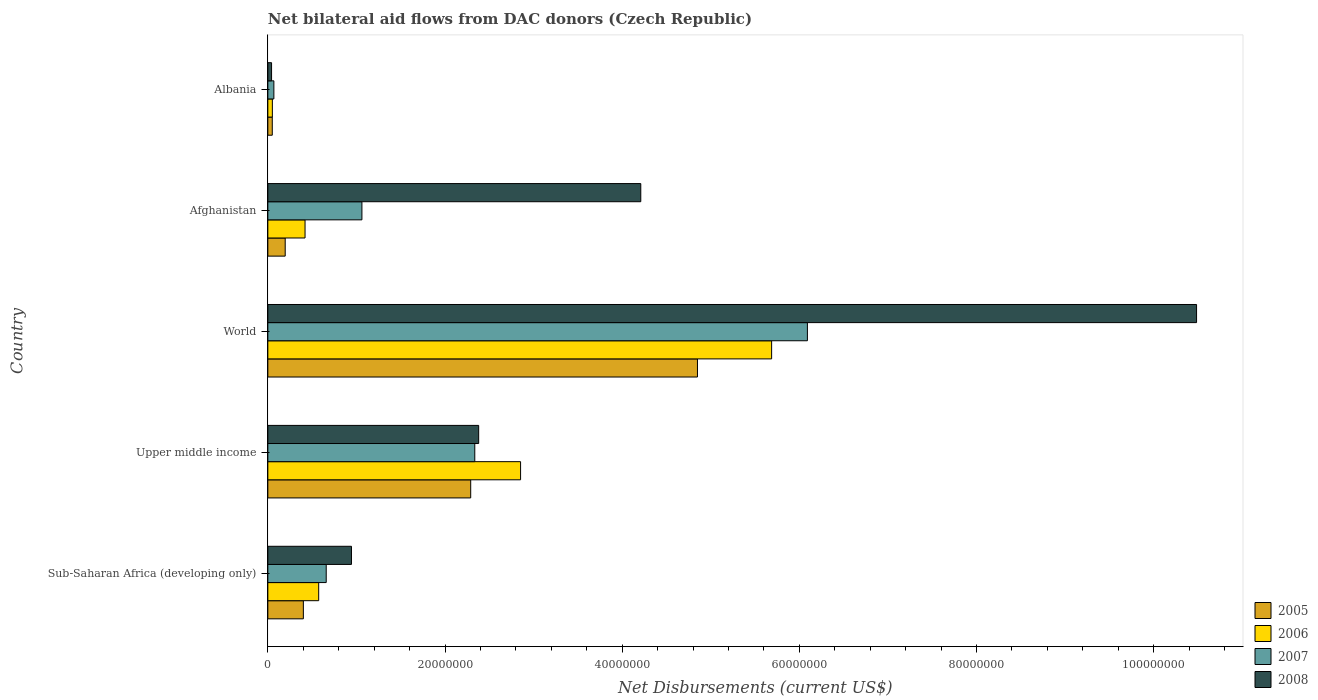How many different coloured bars are there?
Ensure brevity in your answer.  4. Are the number of bars per tick equal to the number of legend labels?
Keep it short and to the point. Yes. Are the number of bars on each tick of the Y-axis equal?
Your answer should be compact. Yes. How many bars are there on the 5th tick from the bottom?
Offer a very short reply. 4. What is the label of the 1st group of bars from the top?
Offer a terse response. Albania. What is the net bilateral aid flows in 2005 in Sub-Saharan Africa (developing only)?
Your answer should be very brief. 4.01e+06. Across all countries, what is the maximum net bilateral aid flows in 2005?
Offer a terse response. 4.85e+07. Across all countries, what is the minimum net bilateral aid flows in 2008?
Keep it short and to the point. 4.20e+05. In which country was the net bilateral aid flows in 2006 maximum?
Your answer should be very brief. World. In which country was the net bilateral aid flows in 2005 minimum?
Provide a short and direct response. Albania. What is the total net bilateral aid flows in 2008 in the graph?
Keep it short and to the point. 1.81e+08. What is the difference between the net bilateral aid flows in 2006 in Afghanistan and that in Upper middle income?
Ensure brevity in your answer.  -2.43e+07. What is the difference between the net bilateral aid flows in 2007 in World and the net bilateral aid flows in 2006 in Upper middle income?
Provide a succinct answer. 3.24e+07. What is the average net bilateral aid flows in 2005 per country?
Offer a very short reply. 1.56e+07. What is the difference between the net bilateral aid flows in 2005 and net bilateral aid flows in 2006 in Upper middle income?
Make the answer very short. -5.63e+06. What is the ratio of the net bilateral aid flows in 2008 in Albania to that in World?
Offer a very short reply. 0. Is the difference between the net bilateral aid flows in 2005 in Upper middle income and World greater than the difference between the net bilateral aid flows in 2006 in Upper middle income and World?
Make the answer very short. Yes. What is the difference between the highest and the second highest net bilateral aid flows in 2008?
Offer a very short reply. 6.27e+07. What is the difference between the highest and the lowest net bilateral aid flows in 2007?
Your answer should be compact. 6.02e+07. Is it the case that in every country, the sum of the net bilateral aid flows in 2007 and net bilateral aid flows in 2008 is greater than the sum of net bilateral aid flows in 2006 and net bilateral aid flows in 2005?
Provide a short and direct response. No. What does the 4th bar from the top in World represents?
Offer a very short reply. 2005. What does the 3rd bar from the bottom in Upper middle income represents?
Offer a very short reply. 2007. How many bars are there?
Offer a terse response. 20. Are all the bars in the graph horizontal?
Provide a short and direct response. Yes. What is the difference between two consecutive major ticks on the X-axis?
Your answer should be very brief. 2.00e+07. Are the values on the major ticks of X-axis written in scientific E-notation?
Make the answer very short. No. Does the graph contain grids?
Provide a short and direct response. No. How many legend labels are there?
Your answer should be very brief. 4. What is the title of the graph?
Give a very brief answer. Net bilateral aid flows from DAC donors (Czech Republic). What is the label or title of the X-axis?
Provide a succinct answer. Net Disbursements (current US$). What is the Net Disbursements (current US$) of 2005 in Sub-Saharan Africa (developing only)?
Your answer should be very brief. 4.01e+06. What is the Net Disbursements (current US$) of 2006 in Sub-Saharan Africa (developing only)?
Make the answer very short. 5.74e+06. What is the Net Disbursements (current US$) of 2007 in Sub-Saharan Africa (developing only)?
Give a very brief answer. 6.59e+06. What is the Net Disbursements (current US$) in 2008 in Sub-Saharan Africa (developing only)?
Your response must be concise. 9.44e+06. What is the Net Disbursements (current US$) of 2005 in Upper middle income?
Provide a succinct answer. 2.29e+07. What is the Net Disbursements (current US$) in 2006 in Upper middle income?
Your answer should be very brief. 2.85e+07. What is the Net Disbursements (current US$) in 2007 in Upper middle income?
Give a very brief answer. 2.34e+07. What is the Net Disbursements (current US$) in 2008 in Upper middle income?
Your response must be concise. 2.38e+07. What is the Net Disbursements (current US$) in 2005 in World?
Your answer should be compact. 4.85e+07. What is the Net Disbursements (current US$) of 2006 in World?
Provide a succinct answer. 5.69e+07. What is the Net Disbursements (current US$) in 2007 in World?
Give a very brief answer. 6.09e+07. What is the Net Disbursements (current US$) of 2008 in World?
Your answer should be compact. 1.05e+08. What is the Net Disbursements (current US$) of 2005 in Afghanistan?
Provide a short and direct response. 1.96e+06. What is the Net Disbursements (current US$) of 2006 in Afghanistan?
Your response must be concise. 4.20e+06. What is the Net Disbursements (current US$) of 2007 in Afghanistan?
Provide a short and direct response. 1.06e+07. What is the Net Disbursements (current US$) in 2008 in Afghanistan?
Offer a very short reply. 4.21e+07. What is the Net Disbursements (current US$) in 2005 in Albania?
Provide a short and direct response. 5.00e+05. What is the Net Disbursements (current US$) of 2006 in Albania?
Your answer should be very brief. 5.10e+05. What is the Net Disbursements (current US$) in 2007 in Albania?
Your answer should be compact. 6.80e+05. Across all countries, what is the maximum Net Disbursements (current US$) of 2005?
Your response must be concise. 4.85e+07. Across all countries, what is the maximum Net Disbursements (current US$) of 2006?
Give a very brief answer. 5.69e+07. Across all countries, what is the maximum Net Disbursements (current US$) of 2007?
Give a very brief answer. 6.09e+07. Across all countries, what is the maximum Net Disbursements (current US$) of 2008?
Make the answer very short. 1.05e+08. Across all countries, what is the minimum Net Disbursements (current US$) in 2005?
Make the answer very short. 5.00e+05. Across all countries, what is the minimum Net Disbursements (current US$) of 2006?
Provide a succinct answer. 5.10e+05. Across all countries, what is the minimum Net Disbursements (current US$) in 2007?
Your answer should be compact. 6.80e+05. Across all countries, what is the minimum Net Disbursements (current US$) of 2008?
Your response must be concise. 4.20e+05. What is the total Net Disbursements (current US$) of 2005 in the graph?
Keep it short and to the point. 7.79e+07. What is the total Net Disbursements (current US$) of 2006 in the graph?
Make the answer very short. 9.58e+07. What is the total Net Disbursements (current US$) of 2007 in the graph?
Provide a short and direct response. 1.02e+08. What is the total Net Disbursements (current US$) in 2008 in the graph?
Give a very brief answer. 1.81e+08. What is the difference between the Net Disbursements (current US$) of 2005 in Sub-Saharan Africa (developing only) and that in Upper middle income?
Provide a short and direct response. -1.89e+07. What is the difference between the Net Disbursements (current US$) of 2006 in Sub-Saharan Africa (developing only) and that in Upper middle income?
Your answer should be compact. -2.28e+07. What is the difference between the Net Disbursements (current US$) in 2007 in Sub-Saharan Africa (developing only) and that in Upper middle income?
Ensure brevity in your answer.  -1.68e+07. What is the difference between the Net Disbursements (current US$) of 2008 in Sub-Saharan Africa (developing only) and that in Upper middle income?
Give a very brief answer. -1.44e+07. What is the difference between the Net Disbursements (current US$) in 2005 in Sub-Saharan Africa (developing only) and that in World?
Keep it short and to the point. -4.45e+07. What is the difference between the Net Disbursements (current US$) of 2006 in Sub-Saharan Africa (developing only) and that in World?
Offer a very short reply. -5.11e+07. What is the difference between the Net Disbursements (current US$) in 2007 in Sub-Saharan Africa (developing only) and that in World?
Your answer should be compact. -5.43e+07. What is the difference between the Net Disbursements (current US$) in 2008 in Sub-Saharan Africa (developing only) and that in World?
Offer a very short reply. -9.54e+07. What is the difference between the Net Disbursements (current US$) in 2005 in Sub-Saharan Africa (developing only) and that in Afghanistan?
Offer a very short reply. 2.05e+06. What is the difference between the Net Disbursements (current US$) of 2006 in Sub-Saharan Africa (developing only) and that in Afghanistan?
Keep it short and to the point. 1.54e+06. What is the difference between the Net Disbursements (current US$) in 2007 in Sub-Saharan Africa (developing only) and that in Afghanistan?
Offer a terse response. -4.03e+06. What is the difference between the Net Disbursements (current US$) of 2008 in Sub-Saharan Africa (developing only) and that in Afghanistan?
Your response must be concise. -3.27e+07. What is the difference between the Net Disbursements (current US$) of 2005 in Sub-Saharan Africa (developing only) and that in Albania?
Offer a terse response. 3.51e+06. What is the difference between the Net Disbursements (current US$) of 2006 in Sub-Saharan Africa (developing only) and that in Albania?
Ensure brevity in your answer.  5.23e+06. What is the difference between the Net Disbursements (current US$) of 2007 in Sub-Saharan Africa (developing only) and that in Albania?
Give a very brief answer. 5.91e+06. What is the difference between the Net Disbursements (current US$) in 2008 in Sub-Saharan Africa (developing only) and that in Albania?
Offer a very short reply. 9.02e+06. What is the difference between the Net Disbursements (current US$) in 2005 in Upper middle income and that in World?
Give a very brief answer. -2.56e+07. What is the difference between the Net Disbursements (current US$) in 2006 in Upper middle income and that in World?
Offer a very short reply. -2.83e+07. What is the difference between the Net Disbursements (current US$) in 2007 in Upper middle income and that in World?
Give a very brief answer. -3.76e+07. What is the difference between the Net Disbursements (current US$) in 2008 in Upper middle income and that in World?
Keep it short and to the point. -8.10e+07. What is the difference between the Net Disbursements (current US$) of 2005 in Upper middle income and that in Afghanistan?
Give a very brief answer. 2.09e+07. What is the difference between the Net Disbursements (current US$) of 2006 in Upper middle income and that in Afghanistan?
Offer a terse response. 2.43e+07. What is the difference between the Net Disbursements (current US$) in 2007 in Upper middle income and that in Afghanistan?
Ensure brevity in your answer.  1.27e+07. What is the difference between the Net Disbursements (current US$) in 2008 in Upper middle income and that in Afghanistan?
Ensure brevity in your answer.  -1.83e+07. What is the difference between the Net Disbursements (current US$) in 2005 in Upper middle income and that in Albania?
Offer a very short reply. 2.24e+07. What is the difference between the Net Disbursements (current US$) of 2006 in Upper middle income and that in Albania?
Your answer should be compact. 2.80e+07. What is the difference between the Net Disbursements (current US$) of 2007 in Upper middle income and that in Albania?
Your answer should be very brief. 2.27e+07. What is the difference between the Net Disbursements (current US$) of 2008 in Upper middle income and that in Albania?
Ensure brevity in your answer.  2.34e+07. What is the difference between the Net Disbursements (current US$) of 2005 in World and that in Afghanistan?
Ensure brevity in your answer.  4.65e+07. What is the difference between the Net Disbursements (current US$) in 2006 in World and that in Afghanistan?
Your answer should be compact. 5.27e+07. What is the difference between the Net Disbursements (current US$) of 2007 in World and that in Afghanistan?
Give a very brief answer. 5.03e+07. What is the difference between the Net Disbursements (current US$) in 2008 in World and that in Afghanistan?
Provide a short and direct response. 6.27e+07. What is the difference between the Net Disbursements (current US$) in 2005 in World and that in Albania?
Keep it short and to the point. 4.80e+07. What is the difference between the Net Disbursements (current US$) of 2006 in World and that in Albania?
Your answer should be compact. 5.64e+07. What is the difference between the Net Disbursements (current US$) in 2007 in World and that in Albania?
Your answer should be compact. 6.02e+07. What is the difference between the Net Disbursements (current US$) of 2008 in World and that in Albania?
Provide a short and direct response. 1.04e+08. What is the difference between the Net Disbursements (current US$) in 2005 in Afghanistan and that in Albania?
Make the answer very short. 1.46e+06. What is the difference between the Net Disbursements (current US$) of 2006 in Afghanistan and that in Albania?
Offer a terse response. 3.69e+06. What is the difference between the Net Disbursements (current US$) of 2007 in Afghanistan and that in Albania?
Ensure brevity in your answer.  9.94e+06. What is the difference between the Net Disbursements (current US$) in 2008 in Afghanistan and that in Albania?
Your answer should be compact. 4.17e+07. What is the difference between the Net Disbursements (current US$) in 2005 in Sub-Saharan Africa (developing only) and the Net Disbursements (current US$) in 2006 in Upper middle income?
Your answer should be compact. -2.45e+07. What is the difference between the Net Disbursements (current US$) of 2005 in Sub-Saharan Africa (developing only) and the Net Disbursements (current US$) of 2007 in Upper middle income?
Your answer should be very brief. -1.94e+07. What is the difference between the Net Disbursements (current US$) of 2005 in Sub-Saharan Africa (developing only) and the Net Disbursements (current US$) of 2008 in Upper middle income?
Your answer should be very brief. -1.98e+07. What is the difference between the Net Disbursements (current US$) in 2006 in Sub-Saharan Africa (developing only) and the Net Disbursements (current US$) in 2007 in Upper middle income?
Your response must be concise. -1.76e+07. What is the difference between the Net Disbursements (current US$) of 2006 in Sub-Saharan Africa (developing only) and the Net Disbursements (current US$) of 2008 in Upper middle income?
Give a very brief answer. -1.81e+07. What is the difference between the Net Disbursements (current US$) in 2007 in Sub-Saharan Africa (developing only) and the Net Disbursements (current US$) in 2008 in Upper middle income?
Keep it short and to the point. -1.72e+07. What is the difference between the Net Disbursements (current US$) of 2005 in Sub-Saharan Africa (developing only) and the Net Disbursements (current US$) of 2006 in World?
Offer a very short reply. -5.29e+07. What is the difference between the Net Disbursements (current US$) of 2005 in Sub-Saharan Africa (developing only) and the Net Disbursements (current US$) of 2007 in World?
Ensure brevity in your answer.  -5.69e+07. What is the difference between the Net Disbursements (current US$) of 2005 in Sub-Saharan Africa (developing only) and the Net Disbursements (current US$) of 2008 in World?
Your response must be concise. -1.01e+08. What is the difference between the Net Disbursements (current US$) of 2006 in Sub-Saharan Africa (developing only) and the Net Disbursements (current US$) of 2007 in World?
Offer a very short reply. -5.52e+07. What is the difference between the Net Disbursements (current US$) of 2006 in Sub-Saharan Africa (developing only) and the Net Disbursements (current US$) of 2008 in World?
Give a very brief answer. -9.91e+07. What is the difference between the Net Disbursements (current US$) of 2007 in Sub-Saharan Africa (developing only) and the Net Disbursements (current US$) of 2008 in World?
Offer a very short reply. -9.82e+07. What is the difference between the Net Disbursements (current US$) of 2005 in Sub-Saharan Africa (developing only) and the Net Disbursements (current US$) of 2006 in Afghanistan?
Your answer should be compact. -1.90e+05. What is the difference between the Net Disbursements (current US$) of 2005 in Sub-Saharan Africa (developing only) and the Net Disbursements (current US$) of 2007 in Afghanistan?
Your response must be concise. -6.61e+06. What is the difference between the Net Disbursements (current US$) in 2005 in Sub-Saharan Africa (developing only) and the Net Disbursements (current US$) in 2008 in Afghanistan?
Give a very brief answer. -3.81e+07. What is the difference between the Net Disbursements (current US$) in 2006 in Sub-Saharan Africa (developing only) and the Net Disbursements (current US$) in 2007 in Afghanistan?
Offer a very short reply. -4.88e+06. What is the difference between the Net Disbursements (current US$) of 2006 in Sub-Saharan Africa (developing only) and the Net Disbursements (current US$) of 2008 in Afghanistan?
Make the answer very short. -3.64e+07. What is the difference between the Net Disbursements (current US$) of 2007 in Sub-Saharan Africa (developing only) and the Net Disbursements (current US$) of 2008 in Afghanistan?
Provide a short and direct response. -3.55e+07. What is the difference between the Net Disbursements (current US$) of 2005 in Sub-Saharan Africa (developing only) and the Net Disbursements (current US$) of 2006 in Albania?
Your answer should be very brief. 3.50e+06. What is the difference between the Net Disbursements (current US$) in 2005 in Sub-Saharan Africa (developing only) and the Net Disbursements (current US$) in 2007 in Albania?
Keep it short and to the point. 3.33e+06. What is the difference between the Net Disbursements (current US$) in 2005 in Sub-Saharan Africa (developing only) and the Net Disbursements (current US$) in 2008 in Albania?
Your answer should be very brief. 3.59e+06. What is the difference between the Net Disbursements (current US$) of 2006 in Sub-Saharan Africa (developing only) and the Net Disbursements (current US$) of 2007 in Albania?
Your answer should be very brief. 5.06e+06. What is the difference between the Net Disbursements (current US$) in 2006 in Sub-Saharan Africa (developing only) and the Net Disbursements (current US$) in 2008 in Albania?
Provide a succinct answer. 5.32e+06. What is the difference between the Net Disbursements (current US$) in 2007 in Sub-Saharan Africa (developing only) and the Net Disbursements (current US$) in 2008 in Albania?
Keep it short and to the point. 6.17e+06. What is the difference between the Net Disbursements (current US$) of 2005 in Upper middle income and the Net Disbursements (current US$) of 2006 in World?
Keep it short and to the point. -3.40e+07. What is the difference between the Net Disbursements (current US$) of 2005 in Upper middle income and the Net Disbursements (current US$) of 2007 in World?
Offer a terse response. -3.80e+07. What is the difference between the Net Disbursements (current US$) of 2005 in Upper middle income and the Net Disbursements (current US$) of 2008 in World?
Keep it short and to the point. -8.19e+07. What is the difference between the Net Disbursements (current US$) of 2006 in Upper middle income and the Net Disbursements (current US$) of 2007 in World?
Offer a very short reply. -3.24e+07. What is the difference between the Net Disbursements (current US$) in 2006 in Upper middle income and the Net Disbursements (current US$) in 2008 in World?
Make the answer very short. -7.63e+07. What is the difference between the Net Disbursements (current US$) in 2007 in Upper middle income and the Net Disbursements (current US$) in 2008 in World?
Give a very brief answer. -8.15e+07. What is the difference between the Net Disbursements (current US$) of 2005 in Upper middle income and the Net Disbursements (current US$) of 2006 in Afghanistan?
Your answer should be very brief. 1.87e+07. What is the difference between the Net Disbursements (current US$) of 2005 in Upper middle income and the Net Disbursements (current US$) of 2007 in Afghanistan?
Your answer should be very brief. 1.23e+07. What is the difference between the Net Disbursements (current US$) of 2005 in Upper middle income and the Net Disbursements (current US$) of 2008 in Afghanistan?
Your answer should be very brief. -1.92e+07. What is the difference between the Net Disbursements (current US$) of 2006 in Upper middle income and the Net Disbursements (current US$) of 2007 in Afghanistan?
Your answer should be very brief. 1.79e+07. What is the difference between the Net Disbursements (current US$) of 2006 in Upper middle income and the Net Disbursements (current US$) of 2008 in Afghanistan?
Offer a terse response. -1.36e+07. What is the difference between the Net Disbursements (current US$) in 2007 in Upper middle income and the Net Disbursements (current US$) in 2008 in Afghanistan?
Make the answer very short. -1.87e+07. What is the difference between the Net Disbursements (current US$) of 2005 in Upper middle income and the Net Disbursements (current US$) of 2006 in Albania?
Your response must be concise. 2.24e+07. What is the difference between the Net Disbursements (current US$) of 2005 in Upper middle income and the Net Disbursements (current US$) of 2007 in Albania?
Your answer should be very brief. 2.22e+07. What is the difference between the Net Disbursements (current US$) of 2005 in Upper middle income and the Net Disbursements (current US$) of 2008 in Albania?
Your answer should be compact. 2.25e+07. What is the difference between the Net Disbursements (current US$) in 2006 in Upper middle income and the Net Disbursements (current US$) in 2007 in Albania?
Offer a very short reply. 2.78e+07. What is the difference between the Net Disbursements (current US$) in 2006 in Upper middle income and the Net Disbursements (current US$) in 2008 in Albania?
Offer a terse response. 2.81e+07. What is the difference between the Net Disbursements (current US$) in 2007 in Upper middle income and the Net Disbursements (current US$) in 2008 in Albania?
Your response must be concise. 2.29e+07. What is the difference between the Net Disbursements (current US$) in 2005 in World and the Net Disbursements (current US$) in 2006 in Afghanistan?
Give a very brief answer. 4.43e+07. What is the difference between the Net Disbursements (current US$) of 2005 in World and the Net Disbursements (current US$) of 2007 in Afghanistan?
Your answer should be compact. 3.79e+07. What is the difference between the Net Disbursements (current US$) in 2005 in World and the Net Disbursements (current US$) in 2008 in Afghanistan?
Keep it short and to the point. 6.40e+06. What is the difference between the Net Disbursements (current US$) in 2006 in World and the Net Disbursements (current US$) in 2007 in Afghanistan?
Your answer should be compact. 4.62e+07. What is the difference between the Net Disbursements (current US$) in 2006 in World and the Net Disbursements (current US$) in 2008 in Afghanistan?
Offer a very short reply. 1.48e+07. What is the difference between the Net Disbursements (current US$) of 2007 in World and the Net Disbursements (current US$) of 2008 in Afghanistan?
Give a very brief answer. 1.88e+07. What is the difference between the Net Disbursements (current US$) of 2005 in World and the Net Disbursements (current US$) of 2006 in Albania?
Keep it short and to the point. 4.80e+07. What is the difference between the Net Disbursements (current US$) of 2005 in World and the Net Disbursements (current US$) of 2007 in Albania?
Offer a terse response. 4.78e+07. What is the difference between the Net Disbursements (current US$) in 2005 in World and the Net Disbursements (current US$) in 2008 in Albania?
Offer a very short reply. 4.81e+07. What is the difference between the Net Disbursements (current US$) of 2006 in World and the Net Disbursements (current US$) of 2007 in Albania?
Provide a succinct answer. 5.62e+07. What is the difference between the Net Disbursements (current US$) in 2006 in World and the Net Disbursements (current US$) in 2008 in Albania?
Make the answer very short. 5.64e+07. What is the difference between the Net Disbursements (current US$) in 2007 in World and the Net Disbursements (current US$) in 2008 in Albania?
Keep it short and to the point. 6.05e+07. What is the difference between the Net Disbursements (current US$) in 2005 in Afghanistan and the Net Disbursements (current US$) in 2006 in Albania?
Offer a terse response. 1.45e+06. What is the difference between the Net Disbursements (current US$) in 2005 in Afghanistan and the Net Disbursements (current US$) in 2007 in Albania?
Your answer should be very brief. 1.28e+06. What is the difference between the Net Disbursements (current US$) in 2005 in Afghanistan and the Net Disbursements (current US$) in 2008 in Albania?
Keep it short and to the point. 1.54e+06. What is the difference between the Net Disbursements (current US$) of 2006 in Afghanistan and the Net Disbursements (current US$) of 2007 in Albania?
Offer a terse response. 3.52e+06. What is the difference between the Net Disbursements (current US$) in 2006 in Afghanistan and the Net Disbursements (current US$) in 2008 in Albania?
Keep it short and to the point. 3.78e+06. What is the difference between the Net Disbursements (current US$) in 2007 in Afghanistan and the Net Disbursements (current US$) in 2008 in Albania?
Give a very brief answer. 1.02e+07. What is the average Net Disbursements (current US$) in 2005 per country?
Keep it short and to the point. 1.56e+07. What is the average Net Disbursements (current US$) of 2006 per country?
Your response must be concise. 1.92e+07. What is the average Net Disbursements (current US$) in 2007 per country?
Give a very brief answer. 2.04e+07. What is the average Net Disbursements (current US$) in 2008 per country?
Offer a very short reply. 3.61e+07. What is the difference between the Net Disbursements (current US$) of 2005 and Net Disbursements (current US$) of 2006 in Sub-Saharan Africa (developing only)?
Provide a short and direct response. -1.73e+06. What is the difference between the Net Disbursements (current US$) of 2005 and Net Disbursements (current US$) of 2007 in Sub-Saharan Africa (developing only)?
Provide a short and direct response. -2.58e+06. What is the difference between the Net Disbursements (current US$) in 2005 and Net Disbursements (current US$) in 2008 in Sub-Saharan Africa (developing only)?
Offer a terse response. -5.43e+06. What is the difference between the Net Disbursements (current US$) of 2006 and Net Disbursements (current US$) of 2007 in Sub-Saharan Africa (developing only)?
Make the answer very short. -8.50e+05. What is the difference between the Net Disbursements (current US$) in 2006 and Net Disbursements (current US$) in 2008 in Sub-Saharan Africa (developing only)?
Your response must be concise. -3.70e+06. What is the difference between the Net Disbursements (current US$) in 2007 and Net Disbursements (current US$) in 2008 in Sub-Saharan Africa (developing only)?
Your answer should be compact. -2.85e+06. What is the difference between the Net Disbursements (current US$) of 2005 and Net Disbursements (current US$) of 2006 in Upper middle income?
Your answer should be very brief. -5.63e+06. What is the difference between the Net Disbursements (current US$) of 2005 and Net Disbursements (current US$) of 2007 in Upper middle income?
Your response must be concise. -4.60e+05. What is the difference between the Net Disbursements (current US$) in 2005 and Net Disbursements (current US$) in 2008 in Upper middle income?
Provide a succinct answer. -9.00e+05. What is the difference between the Net Disbursements (current US$) in 2006 and Net Disbursements (current US$) in 2007 in Upper middle income?
Ensure brevity in your answer.  5.17e+06. What is the difference between the Net Disbursements (current US$) of 2006 and Net Disbursements (current US$) of 2008 in Upper middle income?
Ensure brevity in your answer.  4.73e+06. What is the difference between the Net Disbursements (current US$) of 2007 and Net Disbursements (current US$) of 2008 in Upper middle income?
Keep it short and to the point. -4.40e+05. What is the difference between the Net Disbursements (current US$) in 2005 and Net Disbursements (current US$) in 2006 in World?
Your answer should be very brief. -8.37e+06. What is the difference between the Net Disbursements (current US$) of 2005 and Net Disbursements (current US$) of 2007 in World?
Give a very brief answer. -1.24e+07. What is the difference between the Net Disbursements (current US$) in 2005 and Net Disbursements (current US$) in 2008 in World?
Offer a terse response. -5.63e+07. What is the difference between the Net Disbursements (current US$) of 2006 and Net Disbursements (current US$) of 2007 in World?
Your answer should be very brief. -4.04e+06. What is the difference between the Net Disbursements (current US$) of 2006 and Net Disbursements (current US$) of 2008 in World?
Ensure brevity in your answer.  -4.80e+07. What is the difference between the Net Disbursements (current US$) of 2007 and Net Disbursements (current US$) of 2008 in World?
Give a very brief answer. -4.39e+07. What is the difference between the Net Disbursements (current US$) in 2005 and Net Disbursements (current US$) in 2006 in Afghanistan?
Give a very brief answer. -2.24e+06. What is the difference between the Net Disbursements (current US$) of 2005 and Net Disbursements (current US$) of 2007 in Afghanistan?
Offer a terse response. -8.66e+06. What is the difference between the Net Disbursements (current US$) in 2005 and Net Disbursements (current US$) in 2008 in Afghanistan?
Your answer should be very brief. -4.01e+07. What is the difference between the Net Disbursements (current US$) in 2006 and Net Disbursements (current US$) in 2007 in Afghanistan?
Give a very brief answer. -6.42e+06. What is the difference between the Net Disbursements (current US$) in 2006 and Net Disbursements (current US$) in 2008 in Afghanistan?
Your answer should be compact. -3.79e+07. What is the difference between the Net Disbursements (current US$) of 2007 and Net Disbursements (current US$) of 2008 in Afghanistan?
Provide a succinct answer. -3.15e+07. What is the difference between the Net Disbursements (current US$) in 2005 and Net Disbursements (current US$) in 2006 in Albania?
Your response must be concise. -10000. What is the difference between the Net Disbursements (current US$) in 2005 and Net Disbursements (current US$) in 2008 in Albania?
Provide a succinct answer. 8.00e+04. What is the ratio of the Net Disbursements (current US$) in 2005 in Sub-Saharan Africa (developing only) to that in Upper middle income?
Keep it short and to the point. 0.18. What is the ratio of the Net Disbursements (current US$) of 2006 in Sub-Saharan Africa (developing only) to that in Upper middle income?
Your answer should be compact. 0.2. What is the ratio of the Net Disbursements (current US$) in 2007 in Sub-Saharan Africa (developing only) to that in Upper middle income?
Offer a terse response. 0.28. What is the ratio of the Net Disbursements (current US$) in 2008 in Sub-Saharan Africa (developing only) to that in Upper middle income?
Your answer should be compact. 0.4. What is the ratio of the Net Disbursements (current US$) in 2005 in Sub-Saharan Africa (developing only) to that in World?
Give a very brief answer. 0.08. What is the ratio of the Net Disbursements (current US$) in 2006 in Sub-Saharan Africa (developing only) to that in World?
Your answer should be very brief. 0.1. What is the ratio of the Net Disbursements (current US$) of 2007 in Sub-Saharan Africa (developing only) to that in World?
Offer a very short reply. 0.11. What is the ratio of the Net Disbursements (current US$) of 2008 in Sub-Saharan Africa (developing only) to that in World?
Your answer should be very brief. 0.09. What is the ratio of the Net Disbursements (current US$) of 2005 in Sub-Saharan Africa (developing only) to that in Afghanistan?
Your answer should be very brief. 2.05. What is the ratio of the Net Disbursements (current US$) in 2006 in Sub-Saharan Africa (developing only) to that in Afghanistan?
Give a very brief answer. 1.37. What is the ratio of the Net Disbursements (current US$) in 2007 in Sub-Saharan Africa (developing only) to that in Afghanistan?
Keep it short and to the point. 0.62. What is the ratio of the Net Disbursements (current US$) in 2008 in Sub-Saharan Africa (developing only) to that in Afghanistan?
Make the answer very short. 0.22. What is the ratio of the Net Disbursements (current US$) of 2005 in Sub-Saharan Africa (developing only) to that in Albania?
Your answer should be compact. 8.02. What is the ratio of the Net Disbursements (current US$) of 2006 in Sub-Saharan Africa (developing only) to that in Albania?
Offer a very short reply. 11.25. What is the ratio of the Net Disbursements (current US$) in 2007 in Sub-Saharan Africa (developing only) to that in Albania?
Ensure brevity in your answer.  9.69. What is the ratio of the Net Disbursements (current US$) of 2008 in Sub-Saharan Africa (developing only) to that in Albania?
Provide a short and direct response. 22.48. What is the ratio of the Net Disbursements (current US$) of 2005 in Upper middle income to that in World?
Your response must be concise. 0.47. What is the ratio of the Net Disbursements (current US$) of 2006 in Upper middle income to that in World?
Give a very brief answer. 0.5. What is the ratio of the Net Disbursements (current US$) in 2007 in Upper middle income to that in World?
Your answer should be compact. 0.38. What is the ratio of the Net Disbursements (current US$) of 2008 in Upper middle income to that in World?
Ensure brevity in your answer.  0.23. What is the ratio of the Net Disbursements (current US$) of 2005 in Upper middle income to that in Afghanistan?
Offer a very short reply. 11.68. What is the ratio of the Net Disbursements (current US$) in 2006 in Upper middle income to that in Afghanistan?
Give a very brief answer. 6.79. What is the ratio of the Net Disbursements (current US$) in 2007 in Upper middle income to that in Afghanistan?
Provide a short and direct response. 2.2. What is the ratio of the Net Disbursements (current US$) in 2008 in Upper middle income to that in Afghanistan?
Make the answer very short. 0.57. What is the ratio of the Net Disbursements (current US$) of 2005 in Upper middle income to that in Albania?
Ensure brevity in your answer.  45.8. What is the ratio of the Net Disbursements (current US$) of 2006 in Upper middle income to that in Albania?
Offer a terse response. 55.94. What is the ratio of the Net Disbursements (current US$) of 2007 in Upper middle income to that in Albania?
Provide a short and direct response. 34.35. What is the ratio of the Net Disbursements (current US$) in 2008 in Upper middle income to that in Albania?
Offer a terse response. 56.67. What is the ratio of the Net Disbursements (current US$) in 2005 in World to that in Afghanistan?
Make the answer very short. 24.74. What is the ratio of the Net Disbursements (current US$) of 2006 in World to that in Afghanistan?
Give a very brief answer. 13.54. What is the ratio of the Net Disbursements (current US$) in 2007 in World to that in Afghanistan?
Ensure brevity in your answer.  5.74. What is the ratio of the Net Disbursements (current US$) of 2008 in World to that in Afghanistan?
Your answer should be very brief. 2.49. What is the ratio of the Net Disbursements (current US$) of 2005 in World to that in Albania?
Keep it short and to the point. 97. What is the ratio of the Net Disbursements (current US$) of 2006 in World to that in Albania?
Keep it short and to the point. 111.51. What is the ratio of the Net Disbursements (current US$) of 2007 in World to that in Albania?
Provide a succinct answer. 89.57. What is the ratio of the Net Disbursements (current US$) in 2008 in World to that in Albania?
Ensure brevity in your answer.  249.62. What is the ratio of the Net Disbursements (current US$) of 2005 in Afghanistan to that in Albania?
Offer a very short reply. 3.92. What is the ratio of the Net Disbursements (current US$) of 2006 in Afghanistan to that in Albania?
Your response must be concise. 8.24. What is the ratio of the Net Disbursements (current US$) in 2007 in Afghanistan to that in Albania?
Give a very brief answer. 15.62. What is the ratio of the Net Disbursements (current US$) of 2008 in Afghanistan to that in Albania?
Give a very brief answer. 100.24. What is the difference between the highest and the second highest Net Disbursements (current US$) in 2005?
Your answer should be very brief. 2.56e+07. What is the difference between the highest and the second highest Net Disbursements (current US$) in 2006?
Ensure brevity in your answer.  2.83e+07. What is the difference between the highest and the second highest Net Disbursements (current US$) in 2007?
Give a very brief answer. 3.76e+07. What is the difference between the highest and the second highest Net Disbursements (current US$) in 2008?
Offer a very short reply. 6.27e+07. What is the difference between the highest and the lowest Net Disbursements (current US$) in 2005?
Provide a succinct answer. 4.80e+07. What is the difference between the highest and the lowest Net Disbursements (current US$) in 2006?
Offer a very short reply. 5.64e+07. What is the difference between the highest and the lowest Net Disbursements (current US$) of 2007?
Provide a succinct answer. 6.02e+07. What is the difference between the highest and the lowest Net Disbursements (current US$) in 2008?
Make the answer very short. 1.04e+08. 